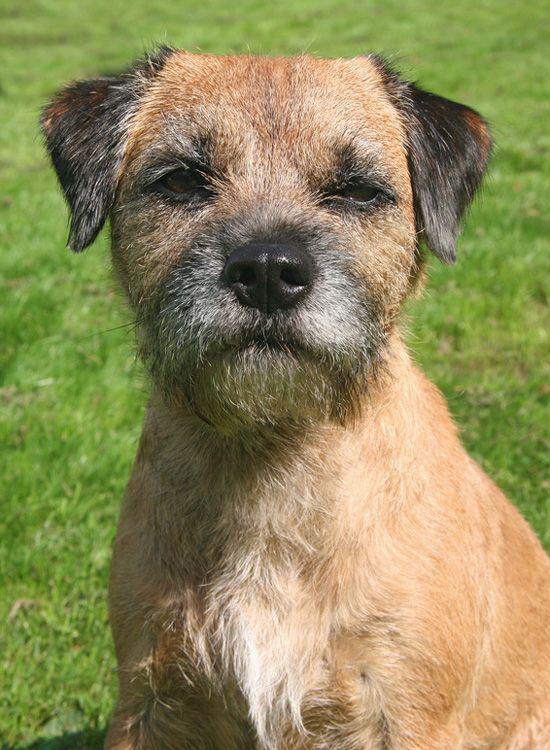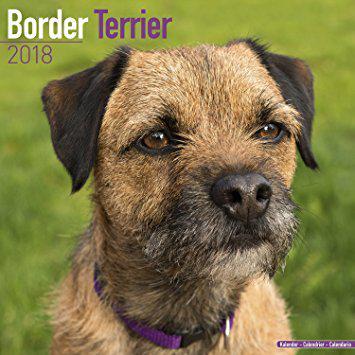The first image is the image on the left, the second image is the image on the right. Evaluate the accuracy of this statement regarding the images: "One image contains twice as many dogs as the other image, and in total, at least two of the dogs depicted face the same direction.". Is it true? Answer yes or no. No. The first image is the image on the left, the second image is the image on the right. Given the left and right images, does the statement "In one of the images, two border terriers are sitting next to each other." hold true? Answer yes or no. No. 